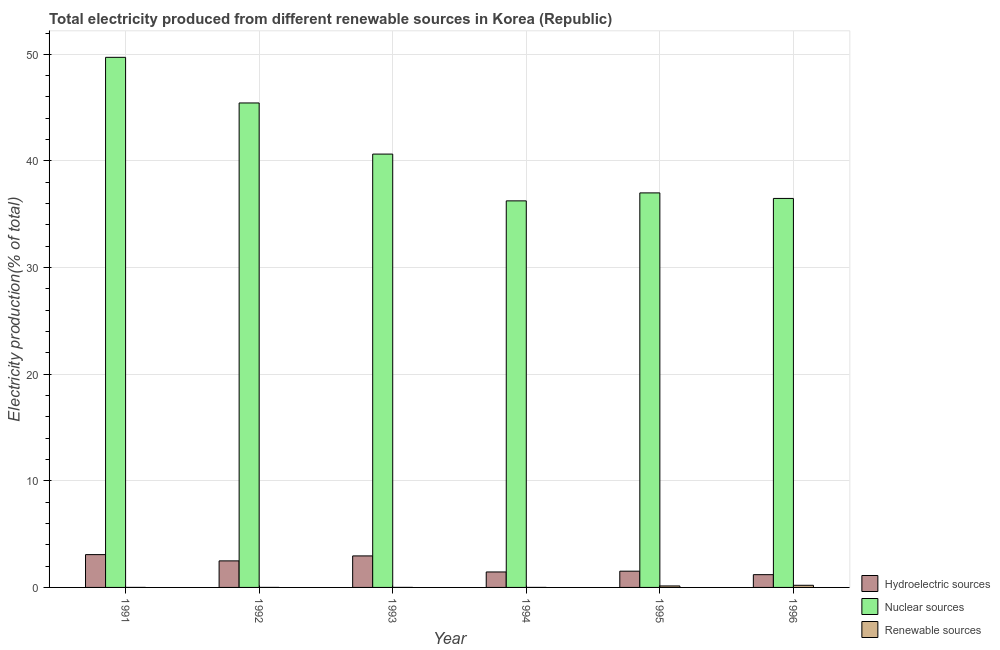How many different coloured bars are there?
Your answer should be compact. 3. How many groups of bars are there?
Ensure brevity in your answer.  6. Are the number of bars on each tick of the X-axis equal?
Provide a short and direct response. Yes. How many bars are there on the 6th tick from the right?
Offer a very short reply. 3. What is the label of the 2nd group of bars from the left?
Your answer should be very brief. 1992. What is the percentage of electricity produced by renewable sources in 1994?
Your answer should be compact. 0. Across all years, what is the maximum percentage of electricity produced by hydroelectric sources?
Your answer should be very brief. 3.08. Across all years, what is the minimum percentage of electricity produced by renewable sources?
Your response must be concise. 0. What is the total percentage of electricity produced by hydroelectric sources in the graph?
Give a very brief answer. 12.69. What is the difference between the percentage of electricity produced by renewable sources in 1991 and that in 1994?
Keep it short and to the point. -0. What is the difference between the percentage of electricity produced by hydroelectric sources in 1992 and the percentage of electricity produced by renewable sources in 1995?
Offer a terse response. 0.97. What is the average percentage of electricity produced by renewable sources per year?
Give a very brief answer. 0.06. In the year 1993, what is the difference between the percentage of electricity produced by hydroelectric sources and percentage of electricity produced by nuclear sources?
Provide a short and direct response. 0. What is the ratio of the percentage of electricity produced by nuclear sources in 1993 to that in 1995?
Provide a succinct answer. 1.1. Is the percentage of electricity produced by renewable sources in 1992 less than that in 1994?
Your answer should be compact. Yes. Is the difference between the percentage of electricity produced by hydroelectric sources in 1992 and 1994 greater than the difference between the percentage of electricity produced by renewable sources in 1992 and 1994?
Give a very brief answer. No. What is the difference between the highest and the second highest percentage of electricity produced by nuclear sources?
Your answer should be very brief. 4.28. What is the difference between the highest and the lowest percentage of electricity produced by hydroelectric sources?
Offer a terse response. 1.88. In how many years, is the percentage of electricity produced by renewable sources greater than the average percentage of electricity produced by renewable sources taken over all years?
Keep it short and to the point. 2. What does the 2nd bar from the left in 1994 represents?
Make the answer very short. Nuclear sources. What does the 3rd bar from the right in 1992 represents?
Offer a very short reply. Hydroelectric sources. Is it the case that in every year, the sum of the percentage of electricity produced by hydroelectric sources and percentage of electricity produced by nuclear sources is greater than the percentage of electricity produced by renewable sources?
Your answer should be very brief. Yes. How many bars are there?
Provide a short and direct response. 18. What is the difference between two consecutive major ticks on the Y-axis?
Provide a succinct answer. 10. Are the values on the major ticks of Y-axis written in scientific E-notation?
Ensure brevity in your answer.  No. Where does the legend appear in the graph?
Ensure brevity in your answer.  Bottom right. How many legend labels are there?
Make the answer very short. 3. How are the legend labels stacked?
Your response must be concise. Vertical. What is the title of the graph?
Keep it short and to the point. Total electricity produced from different renewable sources in Korea (Republic). What is the label or title of the Y-axis?
Offer a very short reply. Electricity production(% of total). What is the Electricity production(% of total) of Hydroelectric sources in 1991?
Give a very brief answer. 3.08. What is the Electricity production(% of total) of Nuclear sources in 1991?
Ensure brevity in your answer.  49.72. What is the Electricity production(% of total) in Renewable sources in 1991?
Your response must be concise. 0. What is the Electricity production(% of total) in Hydroelectric sources in 1992?
Keep it short and to the point. 2.49. What is the Electricity production(% of total) of Nuclear sources in 1992?
Provide a short and direct response. 45.44. What is the Electricity production(% of total) of Renewable sources in 1992?
Provide a short and direct response. 0. What is the Electricity production(% of total) of Hydroelectric sources in 1993?
Make the answer very short. 2.96. What is the Electricity production(% of total) in Nuclear sources in 1993?
Your response must be concise. 40.65. What is the Electricity production(% of total) of Renewable sources in 1993?
Provide a short and direct response. 0. What is the Electricity production(% of total) in Hydroelectric sources in 1994?
Your response must be concise. 1.45. What is the Electricity production(% of total) of Nuclear sources in 1994?
Your response must be concise. 36.26. What is the Electricity production(% of total) of Renewable sources in 1994?
Make the answer very short. 0. What is the Electricity production(% of total) in Hydroelectric sources in 1995?
Your answer should be compact. 1.52. What is the Electricity production(% of total) in Nuclear sources in 1995?
Provide a succinct answer. 37. What is the Electricity production(% of total) of Renewable sources in 1995?
Your answer should be compact. 0.14. What is the Electricity production(% of total) of Hydroelectric sources in 1996?
Your response must be concise. 1.2. What is the Electricity production(% of total) of Nuclear sources in 1996?
Your answer should be compact. 36.49. What is the Electricity production(% of total) in Renewable sources in 1996?
Your response must be concise. 0.2. Across all years, what is the maximum Electricity production(% of total) of Hydroelectric sources?
Offer a very short reply. 3.08. Across all years, what is the maximum Electricity production(% of total) of Nuclear sources?
Provide a short and direct response. 49.72. Across all years, what is the maximum Electricity production(% of total) of Renewable sources?
Your response must be concise. 0.2. Across all years, what is the minimum Electricity production(% of total) in Hydroelectric sources?
Give a very brief answer. 1.2. Across all years, what is the minimum Electricity production(% of total) in Nuclear sources?
Give a very brief answer. 36.26. Across all years, what is the minimum Electricity production(% of total) in Renewable sources?
Your answer should be very brief. 0. What is the total Electricity production(% of total) in Hydroelectric sources in the graph?
Your answer should be compact. 12.69. What is the total Electricity production(% of total) in Nuclear sources in the graph?
Ensure brevity in your answer.  245.56. What is the total Electricity production(% of total) of Renewable sources in the graph?
Provide a succinct answer. 0.35. What is the difference between the Electricity production(% of total) of Hydroelectric sources in 1991 and that in 1992?
Offer a terse response. 0.59. What is the difference between the Electricity production(% of total) of Nuclear sources in 1991 and that in 1992?
Make the answer very short. 4.28. What is the difference between the Electricity production(% of total) in Renewable sources in 1991 and that in 1992?
Your answer should be compact. -0. What is the difference between the Electricity production(% of total) of Hydroelectric sources in 1991 and that in 1993?
Offer a terse response. 0.12. What is the difference between the Electricity production(% of total) of Nuclear sources in 1991 and that in 1993?
Give a very brief answer. 9.07. What is the difference between the Electricity production(% of total) of Renewable sources in 1991 and that in 1993?
Provide a short and direct response. -0. What is the difference between the Electricity production(% of total) of Hydroelectric sources in 1991 and that in 1994?
Provide a succinct answer. 1.63. What is the difference between the Electricity production(% of total) of Nuclear sources in 1991 and that in 1994?
Keep it short and to the point. 13.46. What is the difference between the Electricity production(% of total) in Renewable sources in 1991 and that in 1994?
Keep it short and to the point. -0. What is the difference between the Electricity production(% of total) of Hydroelectric sources in 1991 and that in 1995?
Make the answer very short. 1.55. What is the difference between the Electricity production(% of total) of Nuclear sources in 1991 and that in 1995?
Make the answer very short. 12.72. What is the difference between the Electricity production(% of total) in Renewable sources in 1991 and that in 1995?
Your answer should be compact. -0.14. What is the difference between the Electricity production(% of total) of Hydroelectric sources in 1991 and that in 1996?
Provide a succinct answer. 1.88. What is the difference between the Electricity production(% of total) of Nuclear sources in 1991 and that in 1996?
Your answer should be compact. 13.23. What is the difference between the Electricity production(% of total) of Renewable sources in 1991 and that in 1996?
Your response must be concise. -0.2. What is the difference between the Electricity production(% of total) in Hydroelectric sources in 1992 and that in 1993?
Your answer should be very brief. -0.47. What is the difference between the Electricity production(% of total) of Nuclear sources in 1992 and that in 1993?
Offer a terse response. 4.79. What is the difference between the Electricity production(% of total) of Renewable sources in 1992 and that in 1993?
Your answer should be very brief. -0. What is the difference between the Electricity production(% of total) of Hydroelectric sources in 1992 and that in 1994?
Offer a very short reply. 1.04. What is the difference between the Electricity production(% of total) in Nuclear sources in 1992 and that in 1994?
Provide a succinct answer. 9.18. What is the difference between the Electricity production(% of total) of Renewable sources in 1992 and that in 1994?
Your answer should be very brief. -0. What is the difference between the Electricity production(% of total) in Hydroelectric sources in 1992 and that in 1995?
Make the answer very short. 0.97. What is the difference between the Electricity production(% of total) in Nuclear sources in 1992 and that in 1995?
Make the answer very short. 8.44. What is the difference between the Electricity production(% of total) of Renewable sources in 1992 and that in 1995?
Offer a very short reply. -0.14. What is the difference between the Electricity production(% of total) of Hydroelectric sources in 1992 and that in 1996?
Provide a succinct answer. 1.29. What is the difference between the Electricity production(% of total) of Nuclear sources in 1992 and that in 1996?
Ensure brevity in your answer.  8.95. What is the difference between the Electricity production(% of total) of Renewable sources in 1992 and that in 1996?
Your response must be concise. -0.2. What is the difference between the Electricity production(% of total) in Hydroelectric sources in 1993 and that in 1994?
Your response must be concise. 1.5. What is the difference between the Electricity production(% of total) in Nuclear sources in 1993 and that in 1994?
Your answer should be compact. 4.39. What is the difference between the Electricity production(% of total) in Renewable sources in 1993 and that in 1994?
Your answer should be compact. 0. What is the difference between the Electricity production(% of total) in Hydroelectric sources in 1993 and that in 1995?
Your answer should be compact. 1.43. What is the difference between the Electricity production(% of total) of Nuclear sources in 1993 and that in 1995?
Ensure brevity in your answer.  3.64. What is the difference between the Electricity production(% of total) of Renewable sources in 1993 and that in 1995?
Your answer should be very brief. -0.14. What is the difference between the Electricity production(% of total) of Hydroelectric sources in 1993 and that in 1996?
Ensure brevity in your answer.  1.76. What is the difference between the Electricity production(% of total) in Nuclear sources in 1993 and that in 1996?
Provide a short and direct response. 4.16. What is the difference between the Electricity production(% of total) of Renewable sources in 1993 and that in 1996?
Your response must be concise. -0.2. What is the difference between the Electricity production(% of total) of Hydroelectric sources in 1994 and that in 1995?
Keep it short and to the point. -0.07. What is the difference between the Electricity production(% of total) of Nuclear sources in 1994 and that in 1995?
Provide a succinct answer. -0.75. What is the difference between the Electricity production(% of total) in Renewable sources in 1994 and that in 1995?
Ensure brevity in your answer.  -0.14. What is the difference between the Electricity production(% of total) in Hydroelectric sources in 1994 and that in 1996?
Give a very brief answer. 0.25. What is the difference between the Electricity production(% of total) in Nuclear sources in 1994 and that in 1996?
Your answer should be very brief. -0.23. What is the difference between the Electricity production(% of total) in Renewable sources in 1994 and that in 1996?
Ensure brevity in your answer.  -0.2. What is the difference between the Electricity production(% of total) of Hydroelectric sources in 1995 and that in 1996?
Provide a short and direct response. 0.33. What is the difference between the Electricity production(% of total) in Nuclear sources in 1995 and that in 1996?
Provide a short and direct response. 0.52. What is the difference between the Electricity production(% of total) in Renewable sources in 1995 and that in 1996?
Provide a short and direct response. -0.06. What is the difference between the Electricity production(% of total) of Hydroelectric sources in 1991 and the Electricity production(% of total) of Nuclear sources in 1992?
Make the answer very short. -42.36. What is the difference between the Electricity production(% of total) of Hydroelectric sources in 1991 and the Electricity production(% of total) of Renewable sources in 1992?
Your answer should be very brief. 3.08. What is the difference between the Electricity production(% of total) in Nuclear sources in 1991 and the Electricity production(% of total) in Renewable sources in 1992?
Ensure brevity in your answer.  49.72. What is the difference between the Electricity production(% of total) in Hydroelectric sources in 1991 and the Electricity production(% of total) in Nuclear sources in 1993?
Your response must be concise. -37.57. What is the difference between the Electricity production(% of total) in Hydroelectric sources in 1991 and the Electricity production(% of total) in Renewable sources in 1993?
Give a very brief answer. 3.08. What is the difference between the Electricity production(% of total) of Nuclear sources in 1991 and the Electricity production(% of total) of Renewable sources in 1993?
Provide a short and direct response. 49.72. What is the difference between the Electricity production(% of total) of Hydroelectric sources in 1991 and the Electricity production(% of total) of Nuclear sources in 1994?
Your response must be concise. -33.18. What is the difference between the Electricity production(% of total) in Hydroelectric sources in 1991 and the Electricity production(% of total) in Renewable sources in 1994?
Keep it short and to the point. 3.08. What is the difference between the Electricity production(% of total) in Nuclear sources in 1991 and the Electricity production(% of total) in Renewable sources in 1994?
Keep it short and to the point. 49.72. What is the difference between the Electricity production(% of total) in Hydroelectric sources in 1991 and the Electricity production(% of total) in Nuclear sources in 1995?
Make the answer very short. -33.93. What is the difference between the Electricity production(% of total) in Hydroelectric sources in 1991 and the Electricity production(% of total) in Renewable sources in 1995?
Provide a succinct answer. 2.94. What is the difference between the Electricity production(% of total) of Nuclear sources in 1991 and the Electricity production(% of total) of Renewable sources in 1995?
Offer a terse response. 49.58. What is the difference between the Electricity production(% of total) of Hydroelectric sources in 1991 and the Electricity production(% of total) of Nuclear sources in 1996?
Make the answer very short. -33.41. What is the difference between the Electricity production(% of total) in Hydroelectric sources in 1991 and the Electricity production(% of total) in Renewable sources in 1996?
Provide a succinct answer. 2.88. What is the difference between the Electricity production(% of total) of Nuclear sources in 1991 and the Electricity production(% of total) of Renewable sources in 1996?
Provide a succinct answer. 49.52. What is the difference between the Electricity production(% of total) in Hydroelectric sources in 1992 and the Electricity production(% of total) in Nuclear sources in 1993?
Provide a short and direct response. -38.16. What is the difference between the Electricity production(% of total) in Hydroelectric sources in 1992 and the Electricity production(% of total) in Renewable sources in 1993?
Your answer should be very brief. 2.49. What is the difference between the Electricity production(% of total) in Nuclear sources in 1992 and the Electricity production(% of total) in Renewable sources in 1993?
Your answer should be compact. 45.44. What is the difference between the Electricity production(% of total) of Hydroelectric sources in 1992 and the Electricity production(% of total) of Nuclear sources in 1994?
Make the answer very short. -33.77. What is the difference between the Electricity production(% of total) of Hydroelectric sources in 1992 and the Electricity production(% of total) of Renewable sources in 1994?
Your answer should be very brief. 2.49. What is the difference between the Electricity production(% of total) in Nuclear sources in 1992 and the Electricity production(% of total) in Renewable sources in 1994?
Your answer should be very brief. 45.44. What is the difference between the Electricity production(% of total) of Hydroelectric sources in 1992 and the Electricity production(% of total) of Nuclear sources in 1995?
Your answer should be very brief. -34.51. What is the difference between the Electricity production(% of total) of Hydroelectric sources in 1992 and the Electricity production(% of total) of Renewable sources in 1995?
Your answer should be compact. 2.35. What is the difference between the Electricity production(% of total) in Nuclear sources in 1992 and the Electricity production(% of total) in Renewable sources in 1995?
Offer a very short reply. 45.3. What is the difference between the Electricity production(% of total) in Hydroelectric sources in 1992 and the Electricity production(% of total) in Nuclear sources in 1996?
Make the answer very short. -34. What is the difference between the Electricity production(% of total) in Hydroelectric sources in 1992 and the Electricity production(% of total) in Renewable sources in 1996?
Your answer should be compact. 2.29. What is the difference between the Electricity production(% of total) of Nuclear sources in 1992 and the Electricity production(% of total) of Renewable sources in 1996?
Your answer should be very brief. 45.24. What is the difference between the Electricity production(% of total) of Hydroelectric sources in 1993 and the Electricity production(% of total) of Nuclear sources in 1994?
Your response must be concise. -33.3. What is the difference between the Electricity production(% of total) of Hydroelectric sources in 1993 and the Electricity production(% of total) of Renewable sources in 1994?
Offer a very short reply. 2.95. What is the difference between the Electricity production(% of total) in Nuclear sources in 1993 and the Electricity production(% of total) in Renewable sources in 1994?
Your response must be concise. 40.64. What is the difference between the Electricity production(% of total) of Hydroelectric sources in 1993 and the Electricity production(% of total) of Nuclear sources in 1995?
Your response must be concise. -34.05. What is the difference between the Electricity production(% of total) of Hydroelectric sources in 1993 and the Electricity production(% of total) of Renewable sources in 1995?
Ensure brevity in your answer.  2.82. What is the difference between the Electricity production(% of total) of Nuclear sources in 1993 and the Electricity production(% of total) of Renewable sources in 1995?
Provide a succinct answer. 40.51. What is the difference between the Electricity production(% of total) in Hydroelectric sources in 1993 and the Electricity production(% of total) in Nuclear sources in 1996?
Offer a very short reply. -33.53. What is the difference between the Electricity production(% of total) in Hydroelectric sources in 1993 and the Electricity production(% of total) in Renewable sources in 1996?
Ensure brevity in your answer.  2.75. What is the difference between the Electricity production(% of total) in Nuclear sources in 1993 and the Electricity production(% of total) in Renewable sources in 1996?
Make the answer very short. 40.45. What is the difference between the Electricity production(% of total) in Hydroelectric sources in 1994 and the Electricity production(% of total) in Nuclear sources in 1995?
Keep it short and to the point. -35.55. What is the difference between the Electricity production(% of total) of Hydroelectric sources in 1994 and the Electricity production(% of total) of Renewable sources in 1995?
Keep it short and to the point. 1.31. What is the difference between the Electricity production(% of total) in Nuclear sources in 1994 and the Electricity production(% of total) in Renewable sources in 1995?
Offer a very short reply. 36.12. What is the difference between the Electricity production(% of total) of Hydroelectric sources in 1994 and the Electricity production(% of total) of Nuclear sources in 1996?
Offer a terse response. -35.04. What is the difference between the Electricity production(% of total) of Hydroelectric sources in 1994 and the Electricity production(% of total) of Renewable sources in 1996?
Ensure brevity in your answer.  1.25. What is the difference between the Electricity production(% of total) in Nuclear sources in 1994 and the Electricity production(% of total) in Renewable sources in 1996?
Make the answer very short. 36.06. What is the difference between the Electricity production(% of total) in Hydroelectric sources in 1995 and the Electricity production(% of total) in Nuclear sources in 1996?
Offer a terse response. -34.96. What is the difference between the Electricity production(% of total) of Hydroelectric sources in 1995 and the Electricity production(% of total) of Renewable sources in 1996?
Your response must be concise. 1.32. What is the difference between the Electricity production(% of total) in Nuclear sources in 1995 and the Electricity production(% of total) in Renewable sources in 1996?
Your answer should be very brief. 36.8. What is the average Electricity production(% of total) of Hydroelectric sources per year?
Your answer should be compact. 2.12. What is the average Electricity production(% of total) of Nuclear sources per year?
Your answer should be very brief. 40.93. What is the average Electricity production(% of total) of Renewable sources per year?
Offer a terse response. 0.06. In the year 1991, what is the difference between the Electricity production(% of total) in Hydroelectric sources and Electricity production(% of total) in Nuclear sources?
Provide a short and direct response. -46.64. In the year 1991, what is the difference between the Electricity production(% of total) of Hydroelectric sources and Electricity production(% of total) of Renewable sources?
Keep it short and to the point. 3.08. In the year 1991, what is the difference between the Electricity production(% of total) in Nuclear sources and Electricity production(% of total) in Renewable sources?
Give a very brief answer. 49.72. In the year 1992, what is the difference between the Electricity production(% of total) in Hydroelectric sources and Electricity production(% of total) in Nuclear sources?
Your answer should be very brief. -42.95. In the year 1992, what is the difference between the Electricity production(% of total) of Hydroelectric sources and Electricity production(% of total) of Renewable sources?
Make the answer very short. 2.49. In the year 1992, what is the difference between the Electricity production(% of total) in Nuclear sources and Electricity production(% of total) in Renewable sources?
Give a very brief answer. 45.44. In the year 1993, what is the difference between the Electricity production(% of total) of Hydroelectric sources and Electricity production(% of total) of Nuclear sources?
Your response must be concise. -37.69. In the year 1993, what is the difference between the Electricity production(% of total) in Hydroelectric sources and Electricity production(% of total) in Renewable sources?
Keep it short and to the point. 2.95. In the year 1993, what is the difference between the Electricity production(% of total) in Nuclear sources and Electricity production(% of total) in Renewable sources?
Keep it short and to the point. 40.64. In the year 1994, what is the difference between the Electricity production(% of total) in Hydroelectric sources and Electricity production(% of total) in Nuclear sources?
Your answer should be very brief. -34.81. In the year 1994, what is the difference between the Electricity production(% of total) of Hydroelectric sources and Electricity production(% of total) of Renewable sources?
Keep it short and to the point. 1.45. In the year 1994, what is the difference between the Electricity production(% of total) in Nuclear sources and Electricity production(% of total) in Renewable sources?
Your answer should be compact. 36.26. In the year 1995, what is the difference between the Electricity production(% of total) of Hydroelectric sources and Electricity production(% of total) of Nuclear sources?
Provide a short and direct response. -35.48. In the year 1995, what is the difference between the Electricity production(% of total) of Hydroelectric sources and Electricity production(% of total) of Renewable sources?
Offer a very short reply. 1.38. In the year 1995, what is the difference between the Electricity production(% of total) of Nuclear sources and Electricity production(% of total) of Renewable sources?
Ensure brevity in your answer.  36.87. In the year 1996, what is the difference between the Electricity production(% of total) of Hydroelectric sources and Electricity production(% of total) of Nuclear sources?
Provide a short and direct response. -35.29. In the year 1996, what is the difference between the Electricity production(% of total) in Hydroelectric sources and Electricity production(% of total) in Renewable sources?
Make the answer very short. 1. In the year 1996, what is the difference between the Electricity production(% of total) of Nuclear sources and Electricity production(% of total) of Renewable sources?
Ensure brevity in your answer.  36.29. What is the ratio of the Electricity production(% of total) in Hydroelectric sources in 1991 to that in 1992?
Your answer should be compact. 1.24. What is the ratio of the Electricity production(% of total) of Nuclear sources in 1991 to that in 1992?
Your response must be concise. 1.09. What is the ratio of the Electricity production(% of total) of Renewable sources in 1991 to that in 1992?
Your response must be concise. 0.55. What is the ratio of the Electricity production(% of total) in Hydroelectric sources in 1991 to that in 1993?
Your answer should be very brief. 1.04. What is the ratio of the Electricity production(% of total) of Nuclear sources in 1991 to that in 1993?
Offer a terse response. 1.22. What is the ratio of the Electricity production(% of total) of Renewable sources in 1991 to that in 1993?
Make the answer very short. 0.42. What is the ratio of the Electricity production(% of total) in Hydroelectric sources in 1991 to that in 1994?
Keep it short and to the point. 2.12. What is the ratio of the Electricity production(% of total) in Nuclear sources in 1991 to that in 1994?
Keep it short and to the point. 1.37. What is the ratio of the Electricity production(% of total) in Renewable sources in 1991 to that in 1994?
Your answer should be very brief. 0.48. What is the ratio of the Electricity production(% of total) of Hydroelectric sources in 1991 to that in 1995?
Give a very brief answer. 2.02. What is the ratio of the Electricity production(% of total) in Nuclear sources in 1991 to that in 1995?
Make the answer very short. 1.34. What is the ratio of the Electricity production(% of total) of Renewable sources in 1991 to that in 1995?
Provide a short and direct response. 0.01. What is the ratio of the Electricity production(% of total) of Hydroelectric sources in 1991 to that in 1996?
Keep it short and to the point. 2.57. What is the ratio of the Electricity production(% of total) of Nuclear sources in 1991 to that in 1996?
Keep it short and to the point. 1.36. What is the ratio of the Electricity production(% of total) of Renewable sources in 1991 to that in 1996?
Keep it short and to the point. 0. What is the ratio of the Electricity production(% of total) in Hydroelectric sources in 1992 to that in 1993?
Your response must be concise. 0.84. What is the ratio of the Electricity production(% of total) in Nuclear sources in 1992 to that in 1993?
Keep it short and to the point. 1.12. What is the ratio of the Electricity production(% of total) of Renewable sources in 1992 to that in 1993?
Your answer should be very brief. 0.77. What is the ratio of the Electricity production(% of total) of Hydroelectric sources in 1992 to that in 1994?
Make the answer very short. 1.72. What is the ratio of the Electricity production(% of total) of Nuclear sources in 1992 to that in 1994?
Offer a terse response. 1.25. What is the ratio of the Electricity production(% of total) in Renewable sources in 1992 to that in 1994?
Offer a very short reply. 0.87. What is the ratio of the Electricity production(% of total) of Hydroelectric sources in 1992 to that in 1995?
Keep it short and to the point. 1.63. What is the ratio of the Electricity production(% of total) in Nuclear sources in 1992 to that in 1995?
Provide a short and direct response. 1.23. What is the ratio of the Electricity production(% of total) in Renewable sources in 1992 to that in 1995?
Give a very brief answer. 0.01. What is the ratio of the Electricity production(% of total) of Hydroelectric sources in 1992 to that in 1996?
Your answer should be very brief. 2.08. What is the ratio of the Electricity production(% of total) of Nuclear sources in 1992 to that in 1996?
Offer a very short reply. 1.25. What is the ratio of the Electricity production(% of total) of Renewable sources in 1992 to that in 1996?
Ensure brevity in your answer.  0.01. What is the ratio of the Electricity production(% of total) in Hydroelectric sources in 1993 to that in 1994?
Your answer should be very brief. 2.04. What is the ratio of the Electricity production(% of total) of Nuclear sources in 1993 to that in 1994?
Offer a very short reply. 1.12. What is the ratio of the Electricity production(% of total) of Renewable sources in 1993 to that in 1994?
Your answer should be compact. 1.13. What is the ratio of the Electricity production(% of total) in Hydroelectric sources in 1993 to that in 1995?
Give a very brief answer. 1.94. What is the ratio of the Electricity production(% of total) in Nuclear sources in 1993 to that in 1995?
Offer a terse response. 1.1. What is the ratio of the Electricity production(% of total) of Renewable sources in 1993 to that in 1995?
Ensure brevity in your answer.  0.02. What is the ratio of the Electricity production(% of total) of Hydroelectric sources in 1993 to that in 1996?
Give a very brief answer. 2.47. What is the ratio of the Electricity production(% of total) of Nuclear sources in 1993 to that in 1996?
Provide a short and direct response. 1.11. What is the ratio of the Electricity production(% of total) in Renewable sources in 1993 to that in 1996?
Give a very brief answer. 0.01. What is the ratio of the Electricity production(% of total) of Hydroelectric sources in 1994 to that in 1995?
Offer a terse response. 0.95. What is the ratio of the Electricity production(% of total) of Nuclear sources in 1994 to that in 1995?
Offer a very short reply. 0.98. What is the ratio of the Electricity production(% of total) in Renewable sources in 1994 to that in 1995?
Make the answer very short. 0.01. What is the ratio of the Electricity production(% of total) in Hydroelectric sources in 1994 to that in 1996?
Your answer should be compact. 1.21. What is the ratio of the Electricity production(% of total) in Nuclear sources in 1994 to that in 1996?
Offer a very short reply. 0.99. What is the ratio of the Electricity production(% of total) of Renewable sources in 1994 to that in 1996?
Your answer should be compact. 0.01. What is the ratio of the Electricity production(% of total) in Hydroelectric sources in 1995 to that in 1996?
Your response must be concise. 1.27. What is the ratio of the Electricity production(% of total) of Nuclear sources in 1995 to that in 1996?
Offer a very short reply. 1.01. What is the ratio of the Electricity production(% of total) of Renewable sources in 1995 to that in 1996?
Keep it short and to the point. 0.69. What is the difference between the highest and the second highest Electricity production(% of total) of Hydroelectric sources?
Provide a succinct answer. 0.12. What is the difference between the highest and the second highest Electricity production(% of total) of Nuclear sources?
Give a very brief answer. 4.28. What is the difference between the highest and the second highest Electricity production(% of total) of Renewable sources?
Keep it short and to the point. 0.06. What is the difference between the highest and the lowest Electricity production(% of total) in Hydroelectric sources?
Ensure brevity in your answer.  1.88. What is the difference between the highest and the lowest Electricity production(% of total) in Nuclear sources?
Provide a succinct answer. 13.46. What is the difference between the highest and the lowest Electricity production(% of total) of Renewable sources?
Your response must be concise. 0.2. 